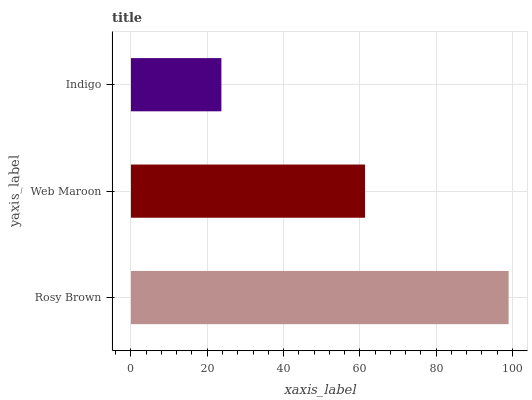Is Indigo the minimum?
Answer yes or no. Yes. Is Rosy Brown the maximum?
Answer yes or no. Yes. Is Web Maroon the minimum?
Answer yes or no. No. Is Web Maroon the maximum?
Answer yes or no. No. Is Rosy Brown greater than Web Maroon?
Answer yes or no. Yes. Is Web Maroon less than Rosy Brown?
Answer yes or no. Yes. Is Web Maroon greater than Rosy Brown?
Answer yes or no. No. Is Rosy Brown less than Web Maroon?
Answer yes or no. No. Is Web Maroon the high median?
Answer yes or no. Yes. Is Web Maroon the low median?
Answer yes or no. Yes. Is Rosy Brown the high median?
Answer yes or no. No. Is Rosy Brown the low median?
Answer yes or no. No. 